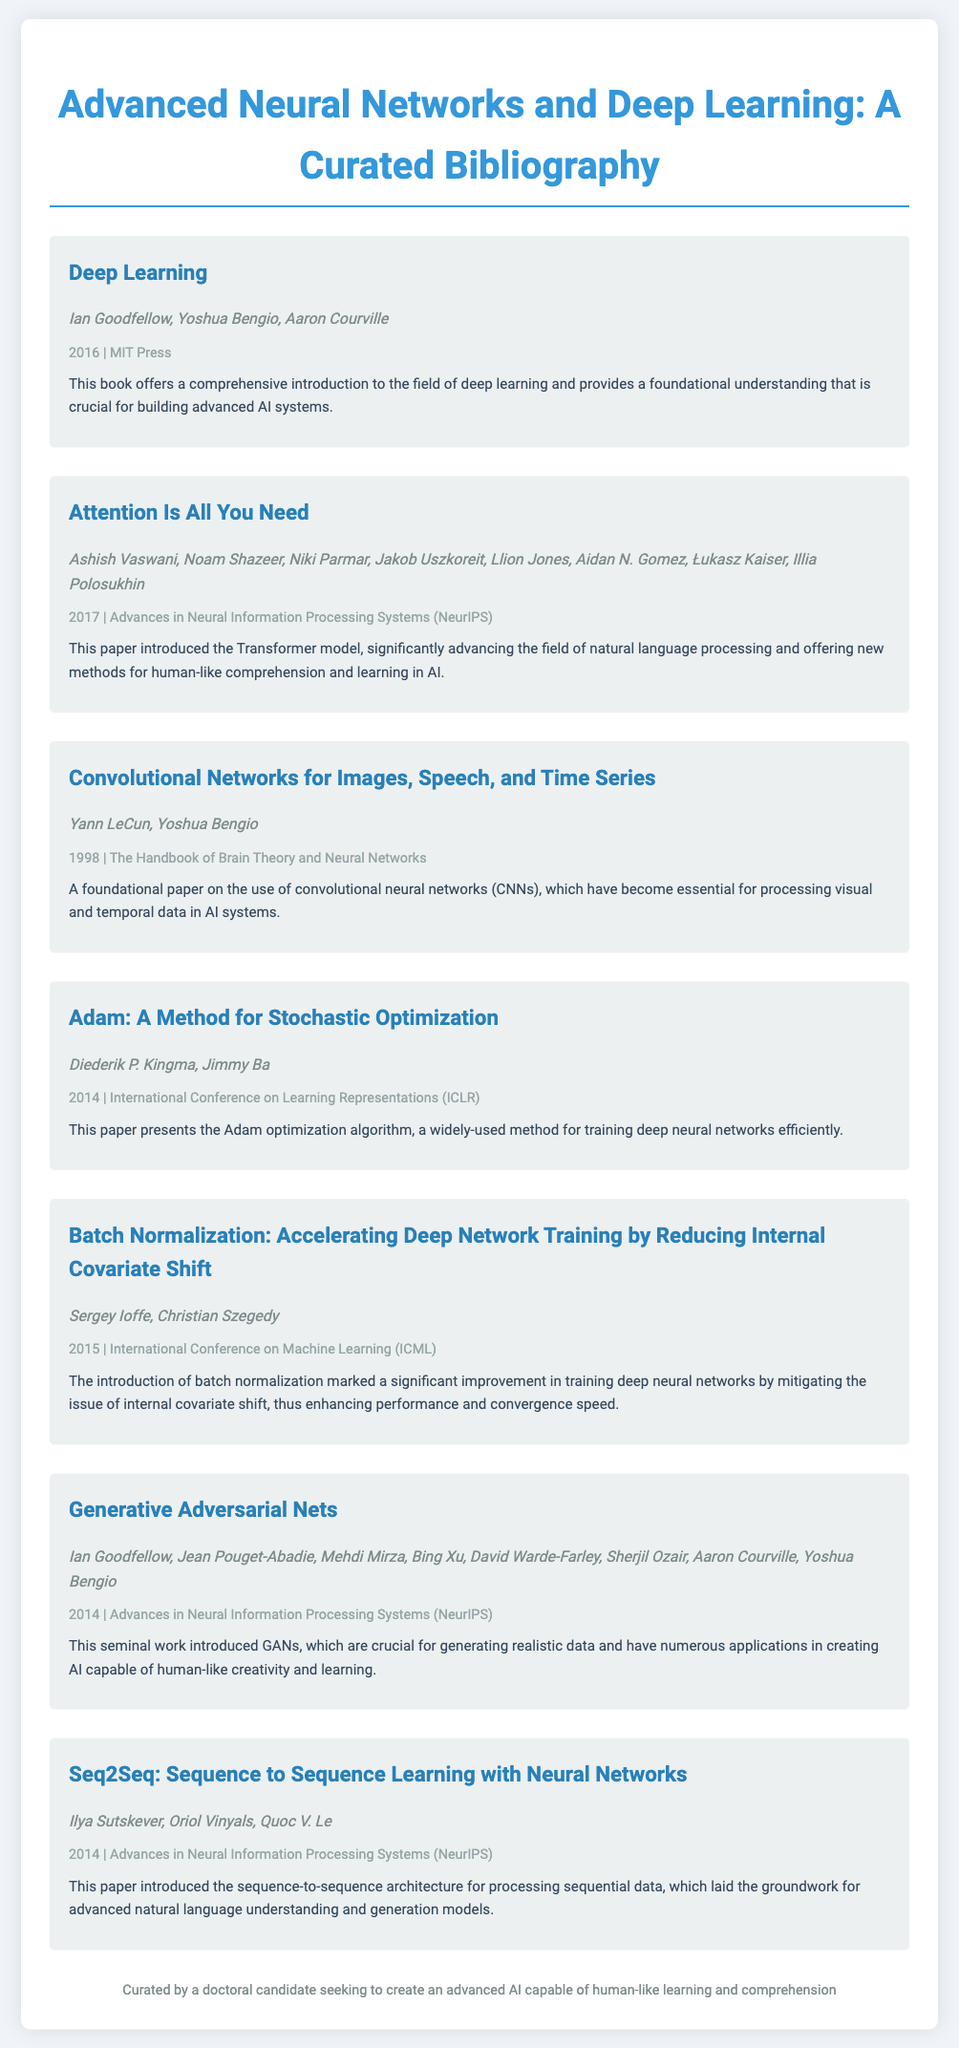What is the title of the book authored by Ian Goodfellow? The title, as mentioned in the bibliography, is "Deep Learning."
Answer: Deep Learning Who are the authors of the paper "Attention Is All You Need"? The authors listed in the bibliography for this paper are Ashish Vaswani, Noam Shazeer, Niki Parmar, Jakob Uszkoreit, Llion Jones, Aidan N. Gomez, Łukasz Kaiser, Illia Polosukhin.
Answer: Ashish Vaswani, Noam Shazeer, Niki Parmar, Jakob Uszkoreit, Llion Jones, Aidan N. Gomez, Łukasz Kaiser, Illia Polosukhin What year was the "Adam: A Method for Stochastic Optimization" published? The publication year for this paper is specified as 2014.
Answer: 2014 Which algorithm was introduced in the paper authored by Diederik P. Kingma and Jimmy Ba? The algorithm discussed in this bibliography entry is Adam.
Answer: Adam What significant issue does batch normalization address in deep networks? The issue stated in the description is the internal covariate shift.
Answer: Internal covariate shift Which foundational concept in AI is introduced by Ian Goodfellow and his collaborators in 2014? The concept introduced is Generative Adversarial Nets (GANs).
Answer: Generative Adversarial Nets How does the "Seq2Seq" paper contribute to natural language processing? It laid the groundwork for advanced natural language understanding and generation models.
Answer: Advanced natural language understanding and generation models What type of network did Yann LeCun and Yoshua Bengio focus on in their 1998 paper? They focused on convolutional neural networks (CNNs).
Answer: Convolutional networks 